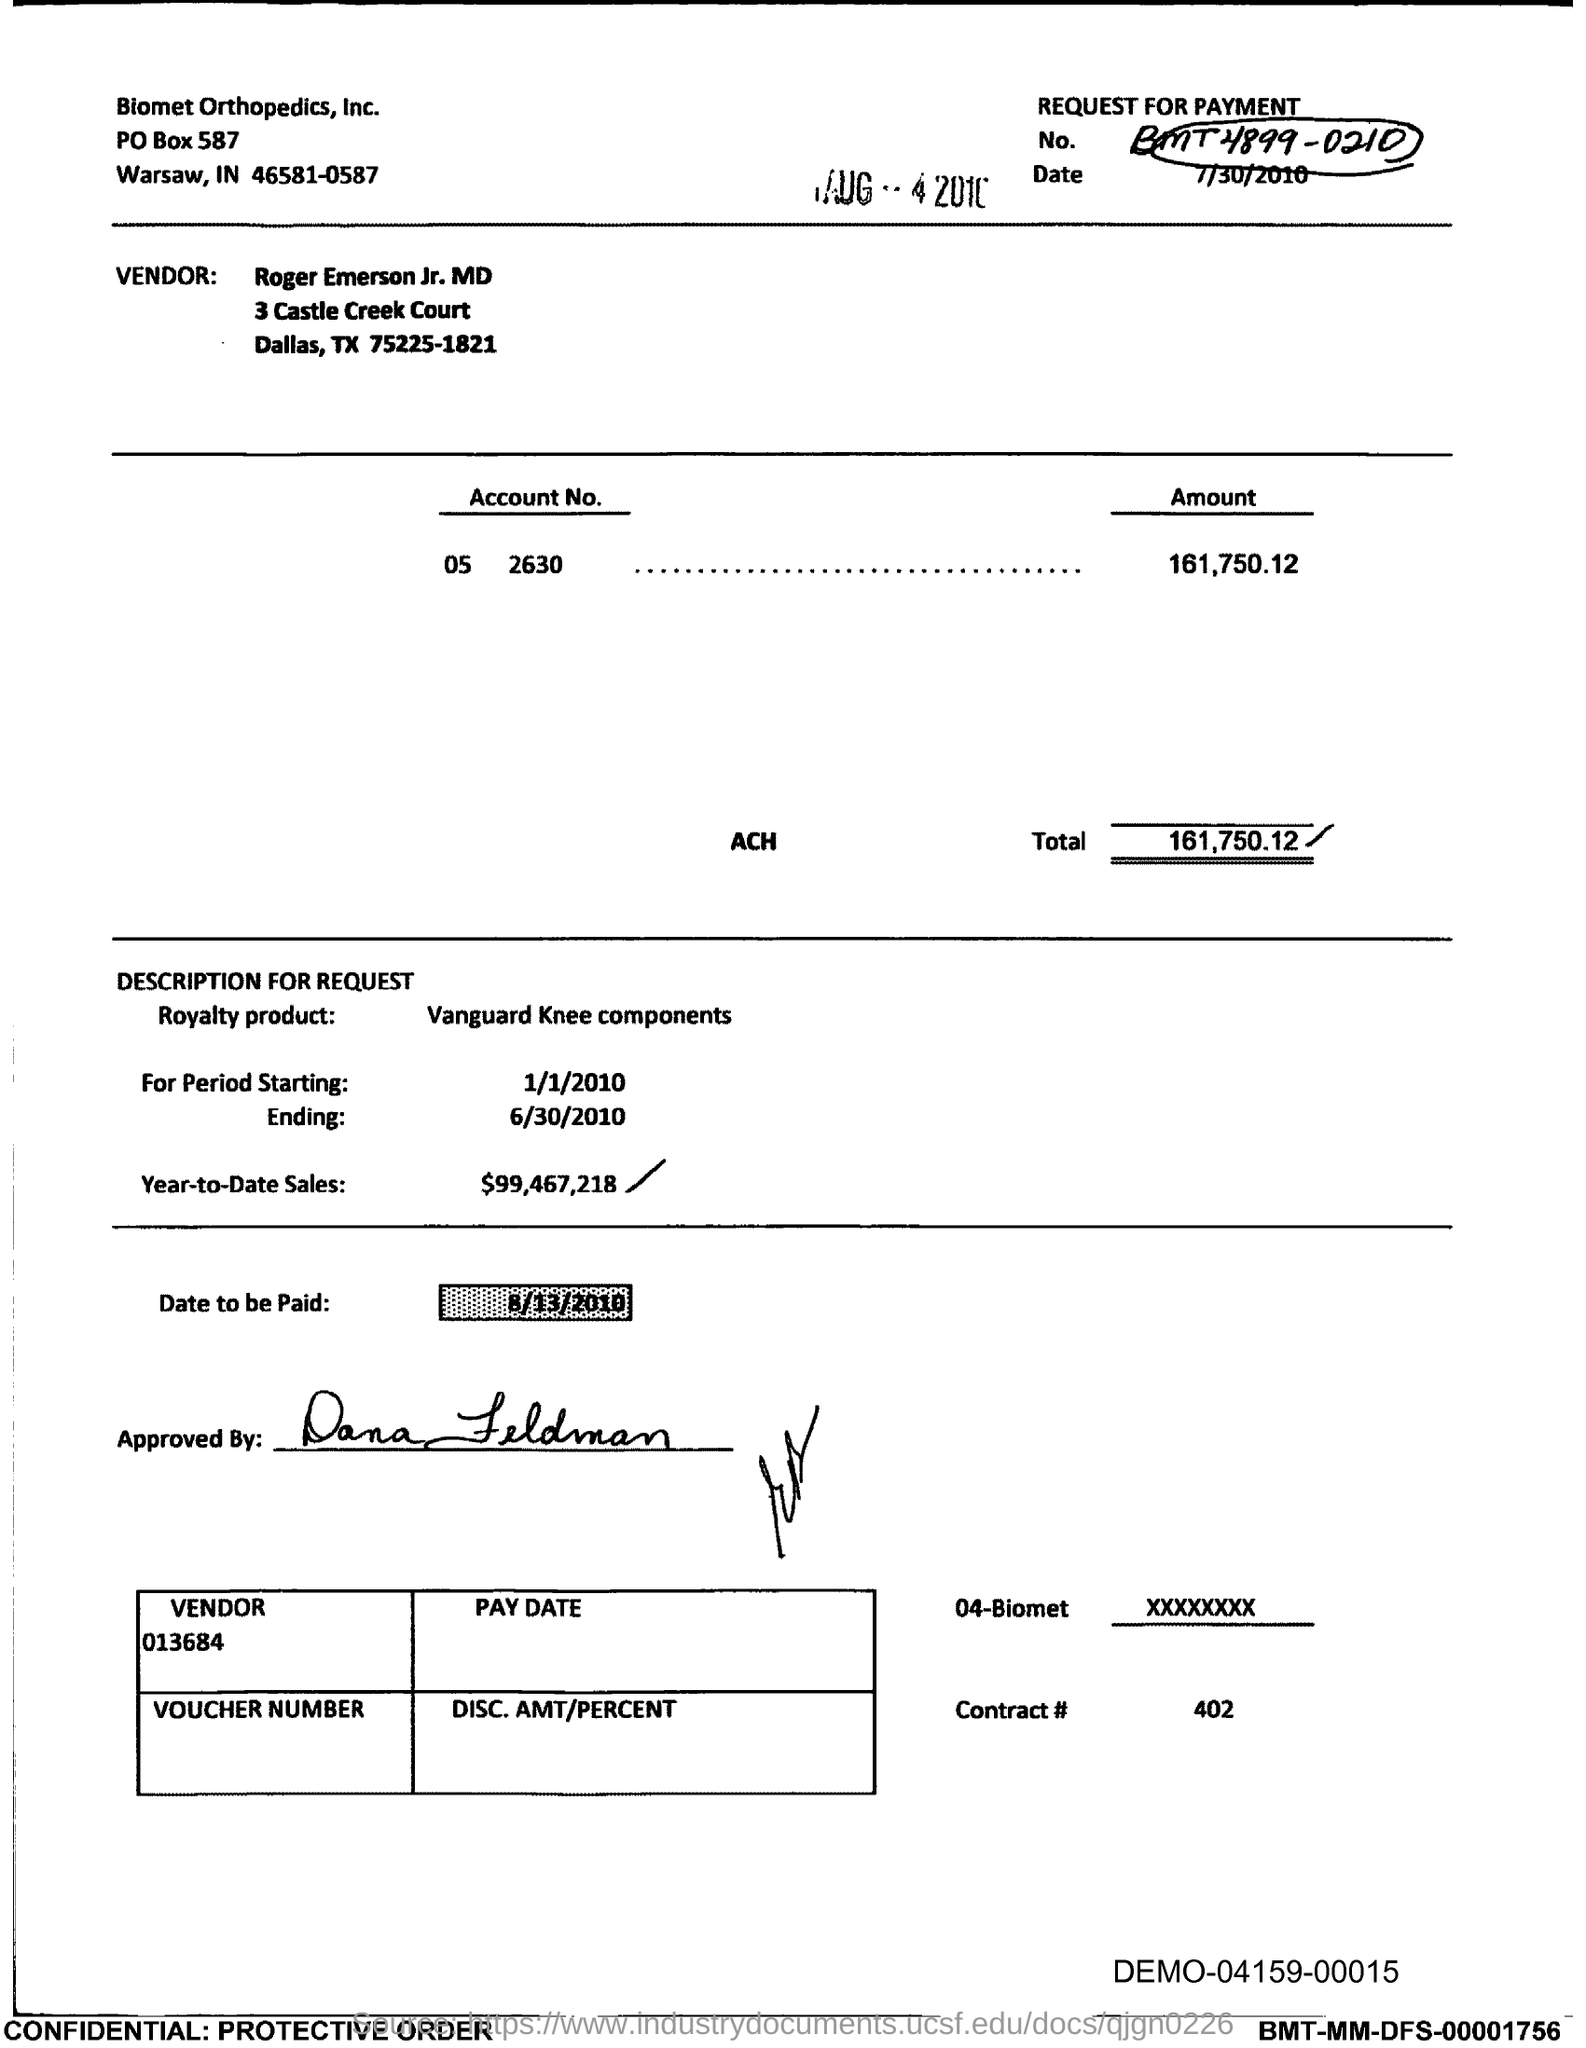What is the Date?
Your response must be concise. 7/30/2010. Who is the Vendor?
Your response must be concise. Roger Emerson Jr. MD. What is the Amount?
Offer a very short reply. 161,750.12. What is the Total?
Your answer should be very brief. 161,750.12. What is the starting period?
Offer a terse response. 1/1/2010. What is the Ending Period?
Your response must be concise. 6/30/2010. What is the Year-to-Date Sales?
Make the answer very short. $99,467,218. 